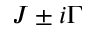Convert formula to latex. <formula><loc_0><loc_0><loc_500><loc_500>J \pm i \Gamma</formula> 